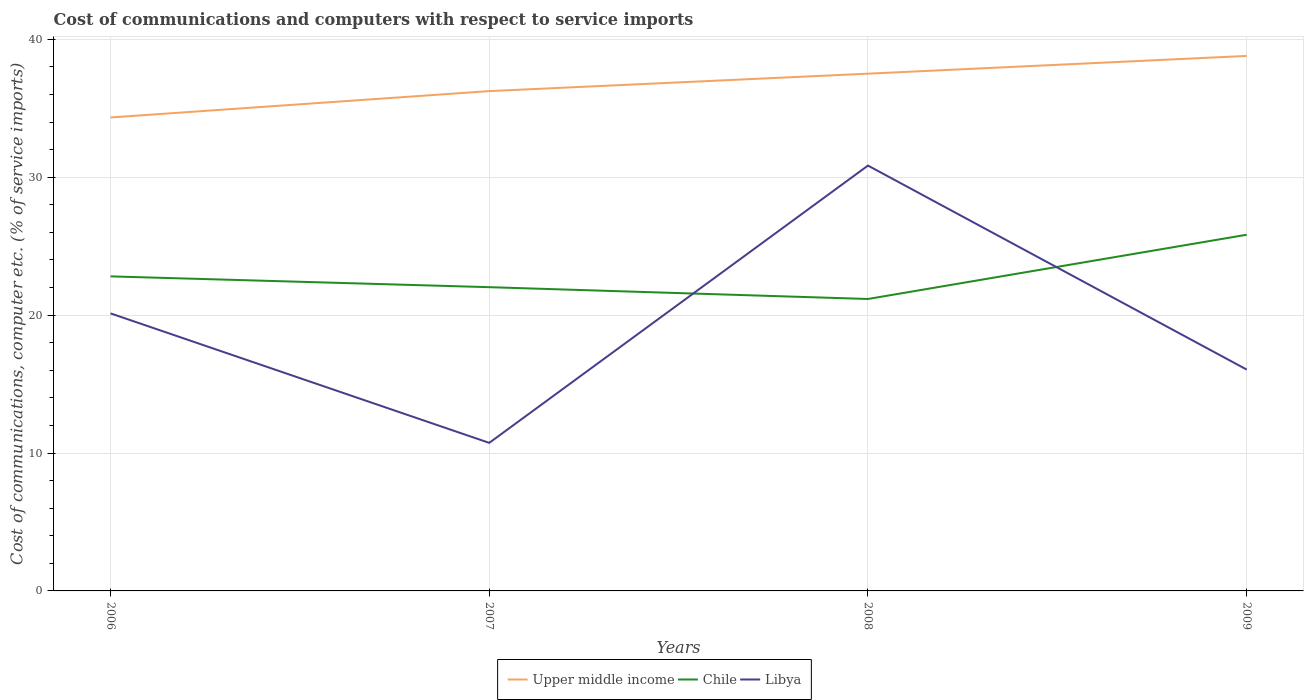How many different coloured lines are there?
Give a very brief answer. 3. Does the line corresponding to Chile intersect with the line corresponding to Libya?
Your response must be concise. Yes. Across all years, what is the maximum cost of communications and computers in Chile?
Provide a short and direct response. 21.17. What is the total cost of communications and computers in Libya in the graph?
Provide a succinct answer. -20.11. What is the difference between the highest and the second highest cost of communications and computers in Chile?
Offer a very short reply. 4.66. Is the cost of communications and computers in Chile strictly greater than the cost of communications and computers in Upper middle income over the years?
Keep it short and to the point. Yes. Are the values on the major ticks of Y-axis written in scientific E-notation?
Your answer should be compact. No. Does the graph contain any zero values?
Provide a succinct answer. No. Does the graph contain grids?
Your answer should be compact. Yes. How many legend labels are there?
Make the answer very short. 3. How are the legend labels stacked?
Keep it short and to the point. Horizontal. What is the title of the graph?
Offer a very short reply. Cost of communications and computers with respect to service imports. What is the label or title of the Y-axis?
Your answer should be compact. Cost of communications, computer etc. (% of service imports). What is the Cost of communications, computer etc. (% of service imports) in Upper middle income in 2006?
Provide a succinct answer. 34.33. What is the Cost of communications, computer etc. (% of service imports) of Chile in 2006?
Provide a short and direct response. 22.81. What is the Cost of communications, computer etc. (% of service imports) of Libya in 2006?
Make the answer very short. 20.12. What is the Cost of communications, computer etc. (% of service imports) of Upper middle income in 2007?
Ensure brevity in your answer.  36.24. What is the Cost of communications, computer etc. (% of service imports) in Chile in 2007?
Provide a short and direct response. 22.02. What is the Cost of communications, computer etc. (% of service imports) in Libya in 2007?
Provide a succinct answer. 10.74. What is the Cost of communications, computer etc. (% of service imports) in Upper middle income in 2008?
Offer a very short reply. 37.5. What is the Cost of communications, computer etc. (% of service imports) in Chile in 2008?
Provide a short and direct response. 21.17. What is the Cost of communications, computer etc. (% of service imports) in Libya in 2008?
Your answer should be very brief. 30.84. What is the Cost of communications, computer etc. (% of service imports) of Upper middle income in 2009?
Make the answer very short. 38.79. What is the Cost of communications, computer etc. (% of service imports) of Chile in 2009?
Make the answer very short. 25.83. What is the Cost of communications, computer etc. (% of service imports) of Libya in 2009?
Keep it short and to the point. 16.05. Across all years, what is the maximum Cost of communications, computer etc. (% of service imports) in Upper middle income?
Make the answer very short. 38.79. Across all years, what is the maximum Cost of communications, computer etc. (% of service imports) of Chile?
Ensure brevity in your answer.  25.83. Across all years, what is the maximum Cost of communications, computer etc. (% of service imports) in Libya?
Your answer should be compact. 30.84. Across all years, what is the minimum Cost of communications, computer etc. (% of service imports) in Upper middle income?
Your response must be concise. 34.33. Across all years, what is the minimum Cost of communications, computer etc. (% of service imports) of Chile?
Provide a succinct answer. 21.17. Across all years, what is the minimum Cost of communications, computer etc. (% of service imports) of Libya?
Ensure brevity in your answer.  10.74. What is the total Cost of communications, computer etc. (% of service imports) of Upper middle income in the graph?
Offer a very short reply. 146.87. What is the total Cost of communications, computer etc. (% of service imports) in Chile in the graph?
Make the answer very short. 91.82. What is the total Cost of communications, computer etc. (% of service imports) of Libya in the graph?
Provide a short and direct response. 77.75. What is the difference between the Cost of communications, computer etc. (% of service imports) in Upper middle income in 2006 and that in 2007?
Make the answer very short. -1.91. What is the difference between the Cost of communications, computer etc. (% of service imports) in Chile in 2006 and that in 2007?
Give a very brief answer. 0.78. What is the difference between the Cost of communications, computer etc. (% of service imports) of Libya in 2006 and that in 2007?
Ensure brevity in your answer.  9.39. What is the difference between the Cost of communications, computer etc. (% of service imports) in Upper middle income in 2006 and that in 2008?
Give a very brief answer. -3.17. What is the difference between the Cost of communications, computer etc. (% of service imports) in Chile in 2006 and that in 2008?
Keep it short and to the point. 1.64. What is the difference between the Cost of communications, computer etc. (% of service imports) in Libya in 2006 and that in 2008?
Offer a very short reply. -10.72. What is the difference between the Cost of communications, computer etc. (% of service imports) in Upper middle income in 2006 and that in 2009?
Offer a terse response. -4.46. What is the difference between the Cost of communications, computer etc. (% of service imports) in Chile in 2006 and that in 2009?
Offer a very short reply. -3.02. What is the difference between the Cost of communications, computer etc. (% of service imports) in Libya in 2006 and that in 2009?
Provide a short and direct response. 4.08. What is the difference between the Cost of communications, computer etc. (% of service imports) of Upper middle income in 2007 and that in 2008?
Provide a succinct answer. -1.26. What is the difference between the Cost of communications, computer etc. (% of service imports) of Chile in 2007 and that in 2008?
Your response must be concise. 0.86. What is the difference between the Cost of communications, computer etc. (% of service imports) in Libya in 2007 and that in 2008?
Your response must be concise. -20.11. What is the difference between the Cost of communications, computer etc. (% of service imports) of Upper middle income in 2007 and that in 2009?
Make the answer very short. -2.55. What is the difference between the Cost of communications, computer etc. (% of service imports) of Chile in 2007 and that in 2009?
Your answer should be compact. -3.8. What is the difference between the Cost of communications, computer etc. (% of service imports) in Libya in 2007 and that in 2009?
Give a very brief answer. -5.31. What is the difference between the Cost of communications, computer etc. (% of service imports) in Upper middle income in 2008 and that in 2009?
Offer a very short reply. -1.29. What is the difference between the Cost of communications, computer etc. (% of service imports) in Chile in 2008 and that in 2009?
Your answer should be very brief. -4.66. What is the difference between the Cost of communications, computer etc. (% of service imports) of Libya in 2008 and that in 2009?
Ensure brevity in your answer.  14.79. What is the difference between the Cost of communications, computer etc. (% of service imports) of Upper middle income in 2006 and the Cost of communications, computer etc. (% of service imports) of Chile in 2007?
Offer a very short reply. 12.31. What is the difference between the Cost of communications, computer etc. (% of service imports) of Upper middle income in 2006 and the Cost of communications, computer etc. (% of service imports) of Libya in 2007?
Your answer should be compact. 23.59. What is the difference between the Cost of communications, computer etc. (% of service imports) of Chile in 2006 and the Cost of communications, computer etc. (% of service imports) of Libya in 2007?
Provide a short and direct response. 12.07. What is the difference between the Cost of communications, computer etc. (% of service imports) in Upper middle income in 2006 and the Cost of communications, computer etc. (% of service imports) in Chile in 2008?
Provide a succinct answer. 13.16. What is the difference between the Cost of communications, computer etc. (% of service imports) of Upper middle income in 2006 and the Cost of communications, computer etc. (% of service imports) of Libya in 2008?
Give a very brief answer. 3.49. What is the difference between the Cost of communications, computer etc. (% of service imports) of Chile in 2006 and the Cost of communications, computer etc. (% of service imports) of Libya in 2008?
Offer a terse response. -8.03. What is the difference between the Cost of communications, computer etc. (% of service imports) in Upper middle income in 2006 and the Cost of communications, computer etc. (% of service imports) in Chile in 2009?
Make the answer very short. 8.5. What is the difference between the Cost of communications, computer etc. (% of service imports) in Upper middle income in 2006 and the Cost of communications, computer etc. (% of service imports) in Libya in 2009?
Make the answer very short. 18.28. What is the difference between the Cost of communications, computer etc. (% of service imports) of Chile in 2006 and the Cost of communications, computer etc. (% of service imports) of Libya in 2009?
Give a very brief answer. 6.76. What is the difference between the Cost of communications, computer etc. (% of service imports) in Upper middle income in 2007 and the Cost of communications, computer etc. (% of service imports) in Chile in 2008?
Your answer should be very brief. 15.07. What is the difference between the Cost of communications, computer etc. (% of service imports) of Upper middle income in 2007 and the Cost of communications, computer etc. (% of service imports) of Libya in 2008?
Your answer should be compact. 5.4. What is the difference between the Cost of communications, computer etc. (% of service imports) in Chile in 2007 and the Cost of communications, computer etc. (% of service imports) in Libya in 2008?
Your response must be concise. -8.82. What is the difference between the Cost of communications, computer etc. (% of service imports) of Upper middle income in 2007 and the Cost of communications, computer etc. (% of service imports) of Chile in 2009?
Offer a terse response. 10.41. What is the difference between the Cost of communications, computer etc. (% of service imports) of Upper middle income in 2007 and the Cost of communications, computer etc. (% of service imports) of Libya in 2009?
Ensure brevity in your answer.  20.19. What is the difference between the Cost of communications, computer etc. (% of service imports) in Chile in 2007 and the Cost of communications, computer etc. (% of service imports) in Libya in 2009?
Your answer should be compact. 5.97. What is the difference between the Cost of communications, computer etc. (% of service imports) of Upper middle income in 2008 and the Cost of communications, computer etc. (% of service imports) of Chile in 2009?
Give a very brief answer. 11.68. What is the difference between the Cost of communications, computer etc. (% of service imports) in Upper middle income in 2008 and the Cost of communications, computer etc. (% of service imports) in Libya in 2009?
Provide a short and direct response. 21.45. What is the difference between the Cost of communications, computer etc. (% of service imports) in Chile in 2008 and the Cost of communications, computer etc. (% of service imports) in Libya in 2009?
Ensure brevity in your answer.  5.12. What is the average Cost of communications, computer etc. (% of service imports) of Upper middle income per year?
Your answer should be compact. 36.72. What is the average Cost of communications, computer etc. (% of service imports) of Chile per year?
Your answer should be very brief. 22.96. What is the average Cost of communications, computer etc. (% of service imports) in Libya per year?
Offer a terse response. 19.44. In the year 2006, what is the difference between the Cost of communications, computer etc. (% of service imports) in Upper middle income and Cost of communications, computer etc. (% of service imports) in Chile?
Offer a very short reply. 11.52. In the year 2006, what is the difference between the Cost of communications, computer etc. (% of service imports) in Upper middle income and Cost of communications, computer etc. (% of service imports) in Libya?
Ensure brevity in your answer.  14.2. In the year 2006, what is the difference between the Cost of communications, computer etc. (% of service imports) in Chile and Cost of communications, computer etc. (% of service imports) in Libya?
Your answer should be compact. 2.68. In the year 2007, what is the difference between the Cost of communications, computer etc. (% of service imports) of Upper middle income and Cost of communications, computer etc. (% of service imports) of Chile?
Offer a terse response. 14.22. In the year 2007, what is the difference between the Cost of communications, computer etc. (% of service imports) of Upper middle income and Cost of communications, computer etc. (% of service imports) of Libya?
Ensure brevity in your answer.  25.5. In the year 2007, what is the difference between the Cost of communications, computer etc. (% of service imports) in Chile and Cost of communications, computer etc. (% of service imports) in Libya?
Your response must be concise. 11.29. In the year 2008, what is the difference between the Cost of communications, computer etc. (% of service imports) of Upper middle income and Cost of communications, computer etc. (% of service imports) of Chile?
Give a very brief answer. 16.34. In the year 2008, what is the difference between the Cost of communications, computer etc. (% of service imports) of Upper middle income and Cost of communications, computer etc. (% of service imports) of Libya?
Keep it short and to the point. 6.66. In the year 2008, what is the difference between the Cost of communications, computer etc. (% of service imports) in Chile and Cost of communications, computer etc. (% of service imports) in Libya?
Make the answer very short. -9.67. In the year 2009, what is the difference between the Cost of communications, computer etc. (% of service imports) in Upper middle income and Cost of communications, computer etc. (% of service imports) in Chile?
Provide a short and direct response. 12.97. In the year 2009, what is the difference between the Cost of communications, computer etc. (% of service imports) of Upper middle income and Cost of communications, computer etc. (% of service imports) of Libya?
Ensure brevity in your answer.  22.74. In the year 2009, what is the difference between the Cost of communications, computer etc. (% of service imports) in Chile and Cost of communications, computer etc. (% of service imports) in Libya?
Offer a terse response. 9.78. What is the ratio of the Cost of communications, computer etc. (% of service imports) of Upper middle income in 2006 to that in 2007?
Your response must be concise. 0.95. What is the ratio of the Cost of communications, computer etc. (% of service imports) in Chile in 2006 to that in 2007?
Offer a terse response. 1.04. What is the ratio of the Cost of communications, computer etc. (% of service imports) in Libya in 2006 to that in 2007?
Your answer should be compact. 1.87. What is the ratio of the Cost of communications, computer etc. (% of service imports) in Upper middle income in 2006 to that in 2008?
Your response must be concise. 0.92. What is the ratio of the Cost of communications, computer etc. (% of service imports) in Chile in 2006 to that in 2008?
Your answer should be very brief. 1.08. What is the ratio of the Cost of communications, computer etc. (% of service imports) in Libya in 2006 to that in 2008?
Your answer should be compact. 0.65. What is the ratio of the Cost of communications, computer etc. (% of service imports) of Upper middle income in 2006 to that in 2009?
Offer a terse response. 0.89. What is the ratio of the Cost of communications, computer etc. (% of service imports) of Chile in 2006 to that in 2009?
Offer a very short reply. 0.88. What is the ratio of the Cost of communications, computer etc. (% of service imports) in Libya in 2006 to that in 2009?
Offer a very short reply. 1.25. What is the ratio of the Cost of communications, computer etc. (% of service imports) in Upper middle income in 2007 to that in 2008?
Provide a succinct answer. 0.97. What is the ratio of the Cost of communications, computer etc. (% of service imports) in Chile in 2007 to that in 2008?
Offer a terse response. 1.04. What is the ratio of the Cost of communications, computer etc. (% of service imports) in Libya in 2007 to that in 2008?
Give a very brief answer. 0.35. What is the ratio of the Cost of communications, computer etc. (% of service imports) of Upper middle income in 2007 to that in 2009?
Offer a very short reply. 0.93. What is the ratio of the Cost of communications, computer etc. (% of service imports) of Chile in 2007 to that in 2009?
Your response must be concise. 0.85. What is the ratio of the Cost of communications, computer etc. (% of service imports) of Libya in 2007 to that in 2009?
Your answer should be compact. 0.67. What is the ratio of the Cost of communications, computer etc. (% of service imports) of Upper middle income in 2008 to that in 2009?
Provide a succinct answer. 0.97. What is the ratio of the Cost of communications, computer etc. (% of service imports) of Chile in 2008 to that in 2009?
Give a very brief answer. 0.82. What is the ratio of the Cost of communications, computer etc. (% of service imports) in Libya in 2008 to that in 2009?
Ensure brevity in your answer.  1.92. What is the difference between the highest and the second highest Cost of communications, computer etc. (% of service imports) in Upper middle income?
Offer a very short reply. 1.29. What is the difference between the highest and the second highest Cost of communications, computer etc. (% of service imports) in Chile?
Your answer should be very brief. 3.02. What is the difference between the highest and the second highest Cost of communications, computer etc. (% of service imports) of Libya?
Give a very brief answer. 10.72. What is the difference between the highest and the lowest Cost of communications, computer etc. (% of service imports) in Upper middle income?
Your response must be concise. 4.46. What is the difference between the highest and the lowest Cost of communications, computer etc. (% of service imports) in Chile?
Your response must be concise. 4.66. What is the difference between the highest and the lowest Cost of communications, computer etc. (% of service imports) of Libya?
Offer a very short reply. 20.11. 